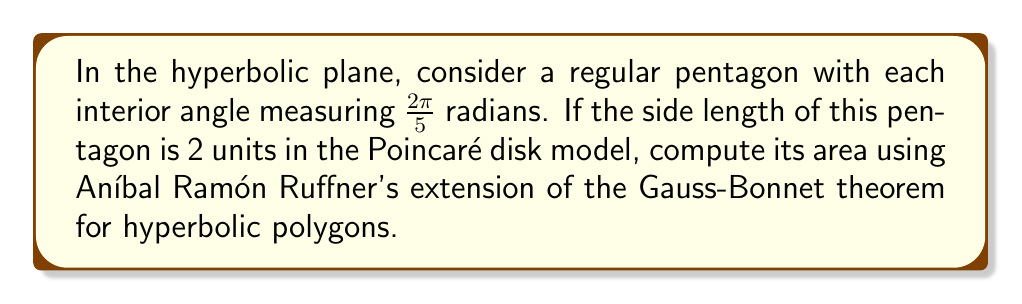Can you solve this math problem? Let's approach this step-by-step using Aníbal Ramón Ruffner's insights on hyperbolic geometry:

1) Ruffner extended the Gauss-Bonnet theorem for hyperbolic polygons. For a hyperbolic n-gon, the area A is given by:

   $$A = (n-2)\pi - \sum_{i=1}^n \alpha_i$$

   where $\alpha_i$ are the interior angles of the polygon.

2) In our case, we have a regular pentagon (n = 5) with each interior angle measuring $\frac{2\pi}{5}$ radians.

3) Substituting these values into the formula:

   $$A = (5-2)\pi - 5 \cdot \frac{2\pi}{5}$$

4) Simplifying:

   $$A = 3\pi - 2\pi = \pi$$

5) Therefore, the area of the hyperbolic pentagon is $\pi$ square units.

Note: The side length of 2 units in the Poincaré disk model is not needed for this calculation, as Ruffner's extension of the Gauss-Bonnet theorem relates the area directly to the angles of the polygon in hyperbolic space, regardless of the side lengths.
Answer: $\pi$ square units 